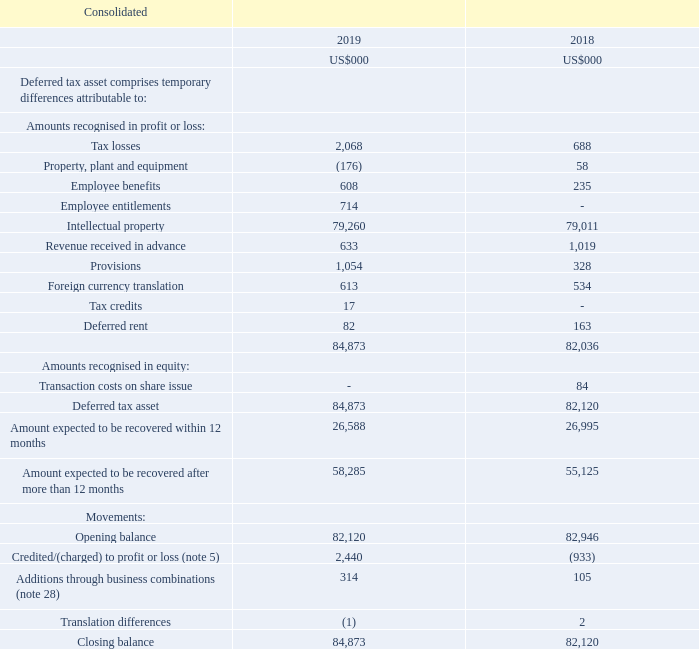Note 11. Non-current assets - deferred tax assets
Critical accounting judgements, estimates and assumptions
Deferred tax assets are recognised for deductible temporary differences only if the Group considers it is probable that future taxable amounts will be available to utilise those temporary differences and losses. Calculation of future taxable amounts involve the use of assumptions and management judgments.
A deferred tax asset can only be recorded for the portion of a potential benefit where utilisation is considered probable. The assessment of future taxable amounts involves the use of assumptions and management judgments. The Group has fully recognised a deferred tax asset of $79.3m in relation to assets previously transferred to USA. It is considered probable that there will be future taxable income in the USA to fully realise these temporary differences.
What is the Tax losses for 2019?
Answer scale should be: thousand. 2,068. When are Deferred tax assets recognized? Only if the group considers it is probable that future taxable amounts will be available to utilise those temporary differences and losses. How are future taxable amounts assessed? Use of assumptions, management judgments. What is the percentage increase in the deferred tax assets from 2018 to 2019?
Answer scale should be: percent. (84,873-82,120)/82,120
Answer: 3.35. What is the percentage increase in amount of intellectual property from 2018 to 2019?
Answer scale should be: percent. (79,260-79,011)/79,011
Answer: 0.32. Which year had the higher Closing balance?  (2019:84,873)>(2018: 82,120 )
Answer: 2019. 